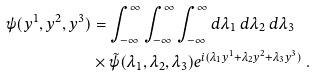<formula> <loc_0><loc_0><loc_500><loc_500>\psi ( y ^ { 1 } , y ^ { 2 } , y ^ { 3 } ) & = \int _ { - \infty } ^ { \infty } \int _ { - \infty } ^ { \infty } \int _ { - \infty } ^ { \infty } d \lambda _ { 1 } \ d \lambda _ { 2 } \ d \lambda _ { 3 } \\ & \times \tilde { \psi } ( \lambda _ { 1 } , \lambda _ { 2 } , \lambda _ { 3 } ) e ^ { i ( \lambda _ { 1 } y ^ { 1 } + \lambda _ { 2 } y ^ { 2 } + \lambda _ { 3 } y ^ { 3 } ) } \ .</formula> 